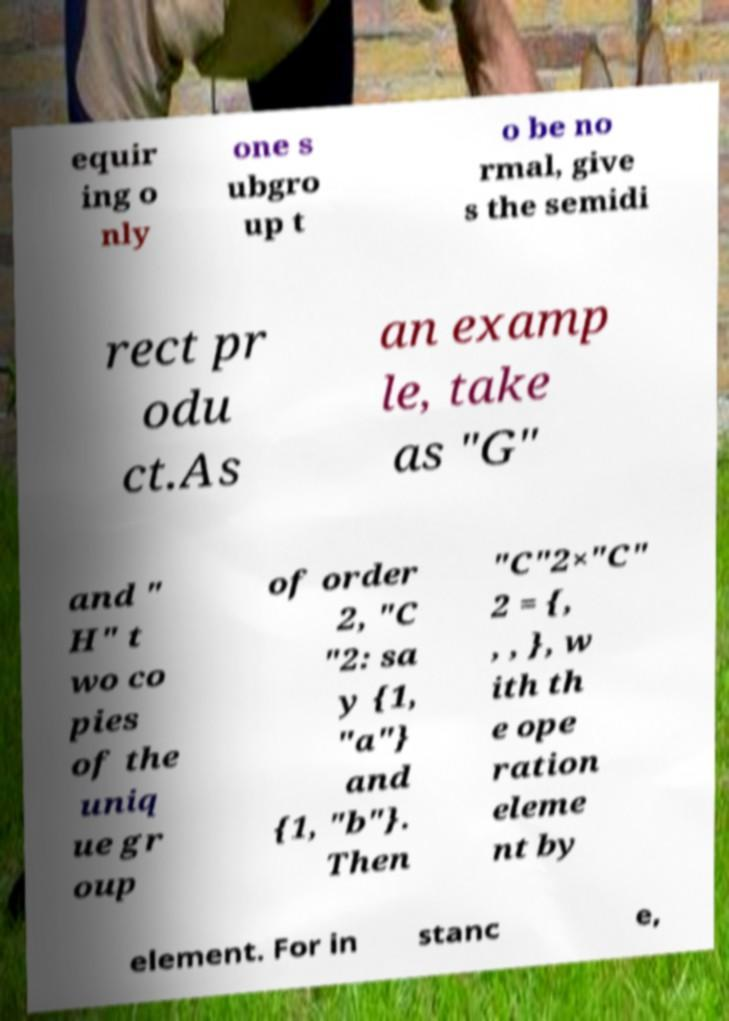Can you read and provide the text displayed in the image?This photo seems to have some interesting text. Can you extract and type it out for me? equir ing o nly one s ubgro up t o be no rmal, give s the semidi rect pr odu ct.As an examp le, take as "G" and " H" t wo co pies of the uniq ue gr oup of order 2, "C "2: sa y {1, "a"} and {1, "b"}. Then "C"2×"C" 2 = {, , , }, w ith th e ope ration eleme nt by element. For in stanc e, 